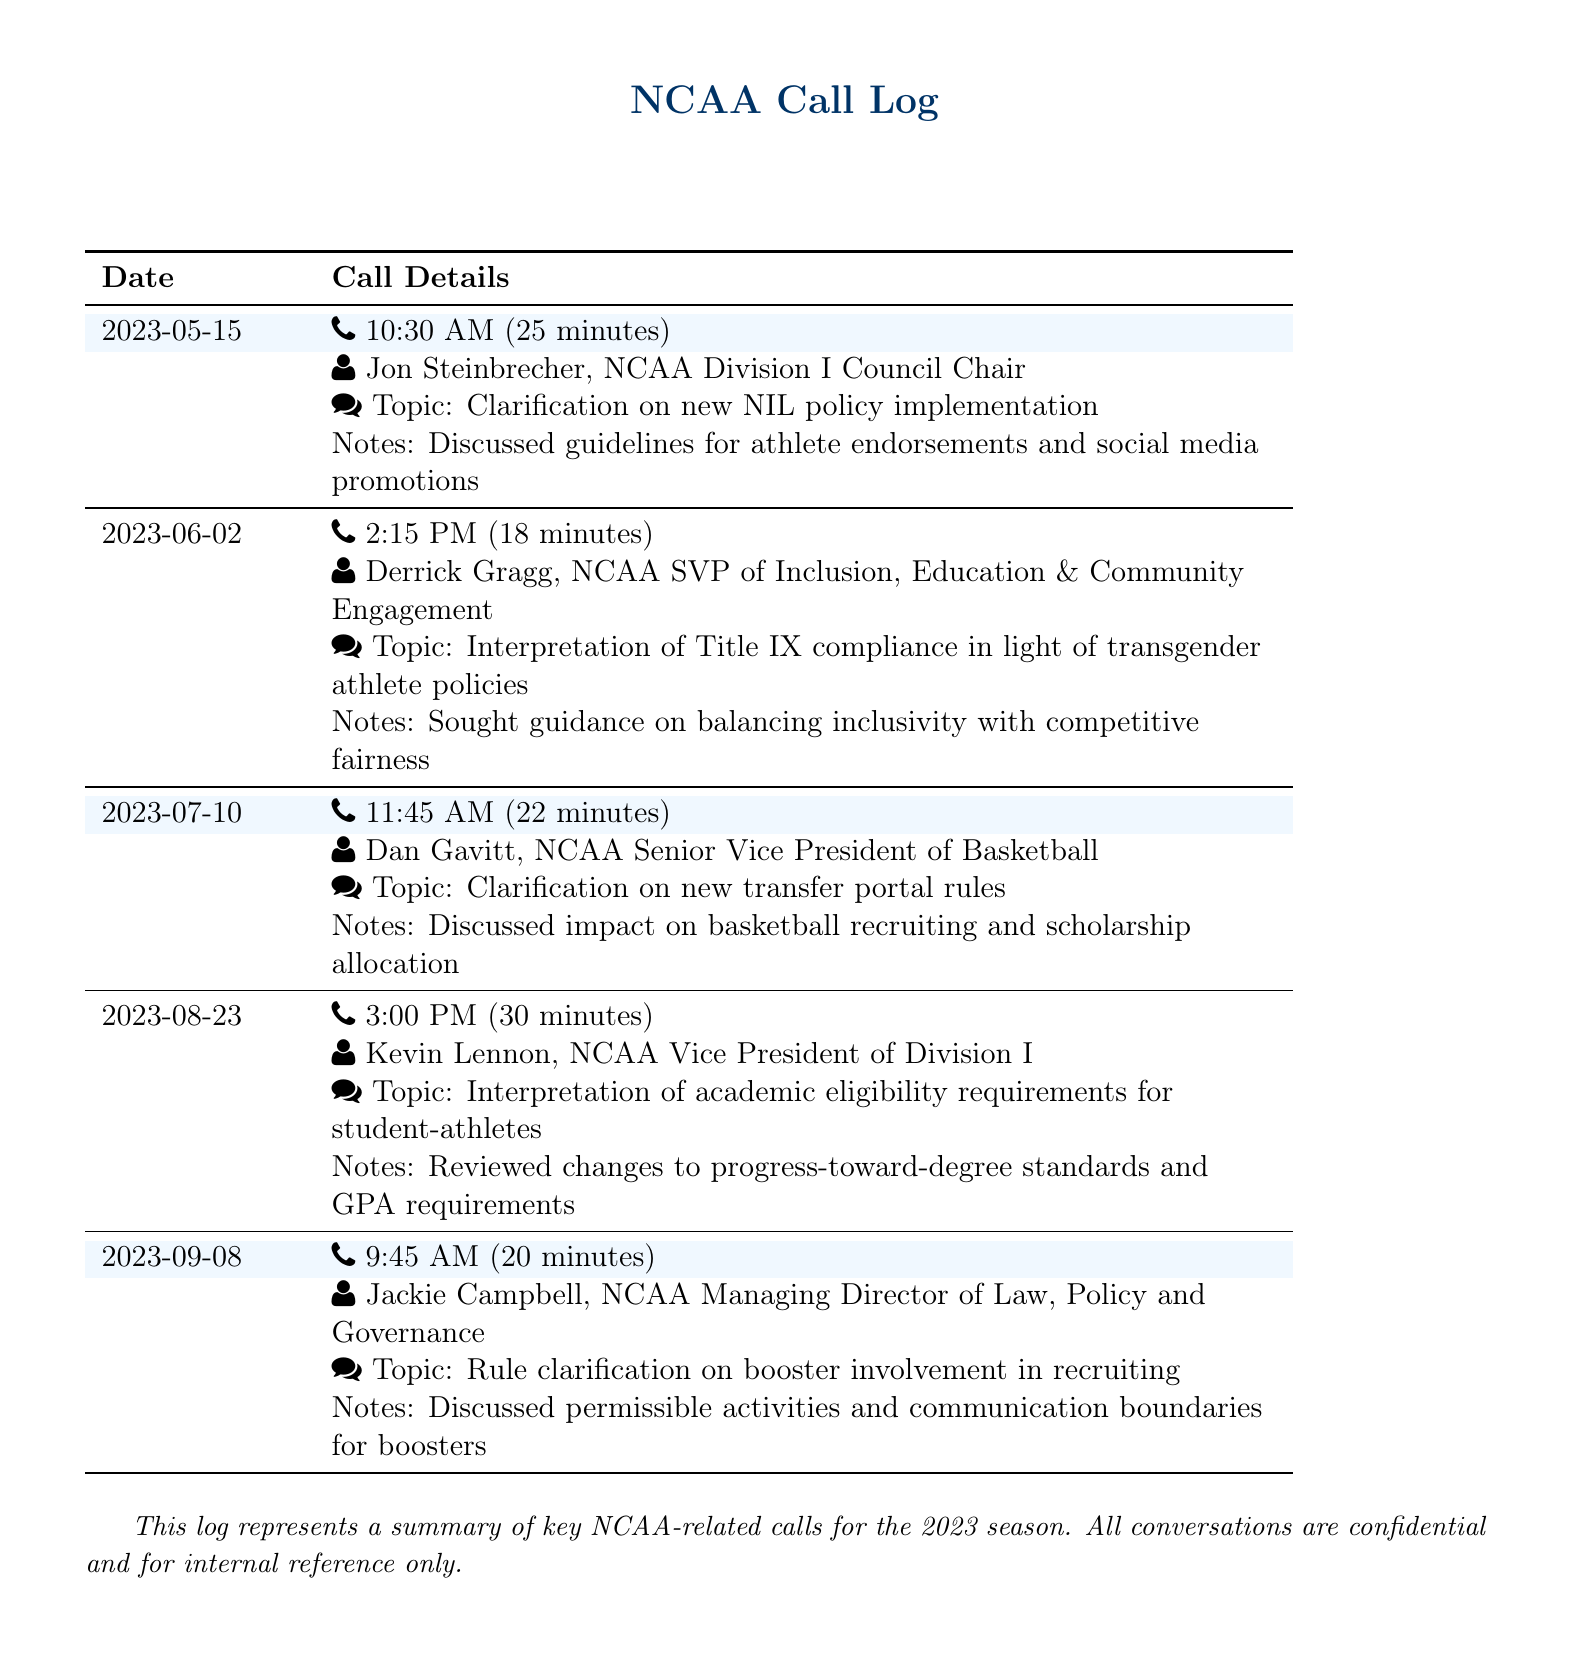What is the date of the call with Jon Steinbrecher? The date is specified in the call log under the call details for Jon Steinbrecher.
Answer: 2023-05-15 How long was the conversation with Derrick Gragg? The duration of the conversation is mentioned in the call log for Derrick Gragg.
Answer: 18 minutes What topic was discussed in the call with Dan Gavitt? The topic is listed in the call details under Dan Gavitt's entry in the log.
Answer: Clarification on new transfer portal rules Who is the NCAA official associated with the call on September 8? The official's name is provided alongside the call details for that date in the log.
Answer: Jackie Campbell What guideline was clarified during the call on May 15? The guideline discussed is noted in the call details for May 15.
Answer: new NIL policy implementation How many calls are recorded in the document? The total number of entries in the call log gives the count of recorded calls.
Answer: 5 What is the main concern raised during the call with Kevin Lennon? The main concern is reflected in the topic discussed during the call with Kevin Lennon.
Answer: academic eligibility requirements for student-athletes What modification was addressed in the conversation with Kevin Lennon? The modification discussed is mentioned in the notes related to Kevin Lennon’s call.
Answer: changes to progress-toward-degree standards 